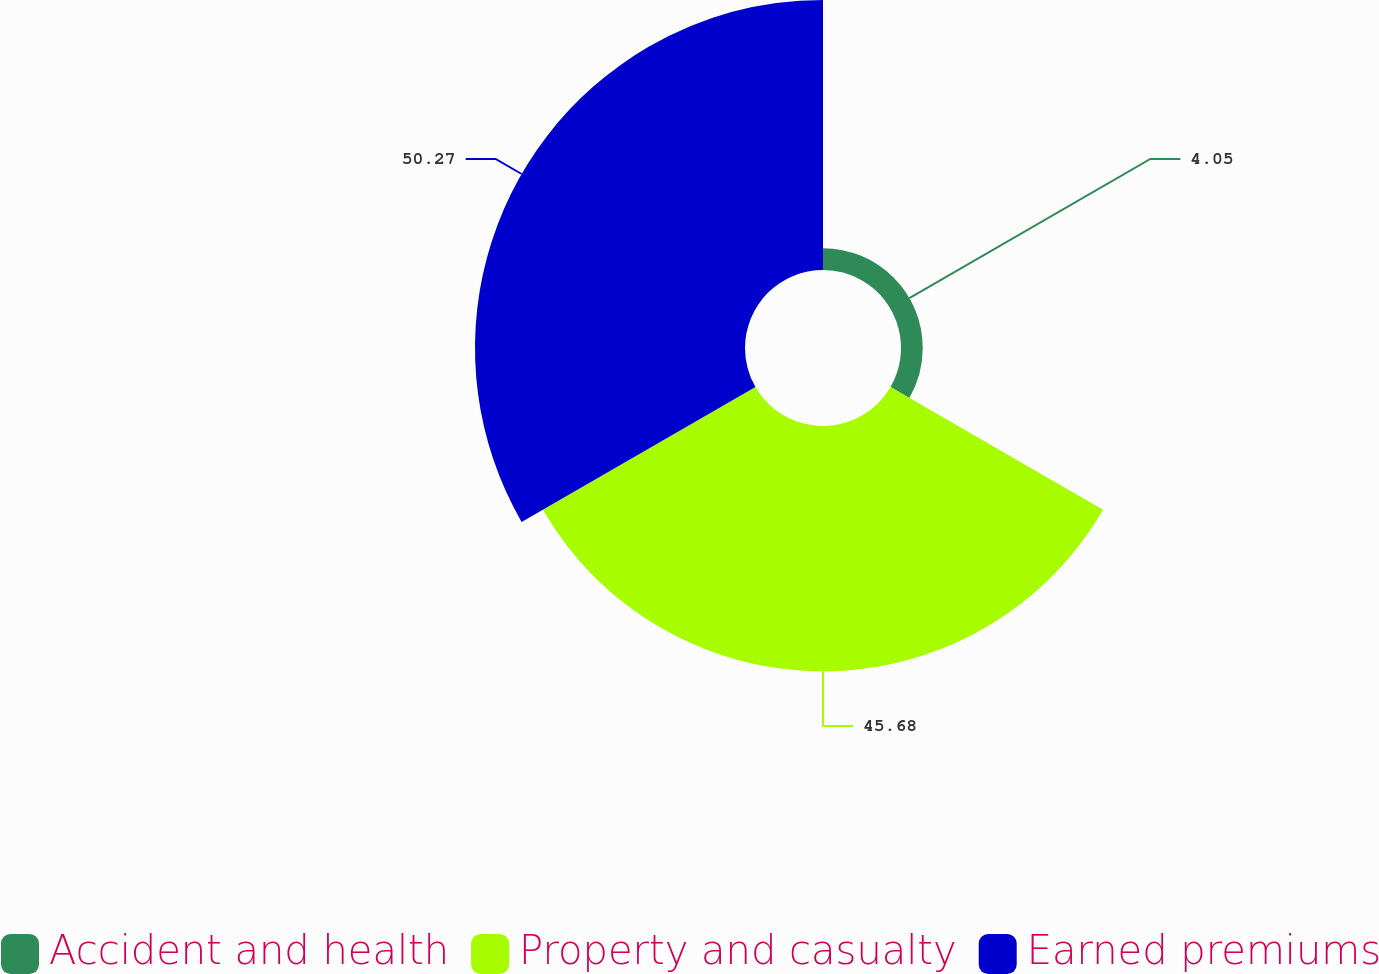Convert chart. <chart><loc_0><loc_0><loc_500><loc_500><pie_chart><fcel>Accident and health<fcel>Property and casualty<fcel>Earned premiums<nl><fcel>4.05%<fcel>45.68%<fcel>50.27%<nl></chart> 